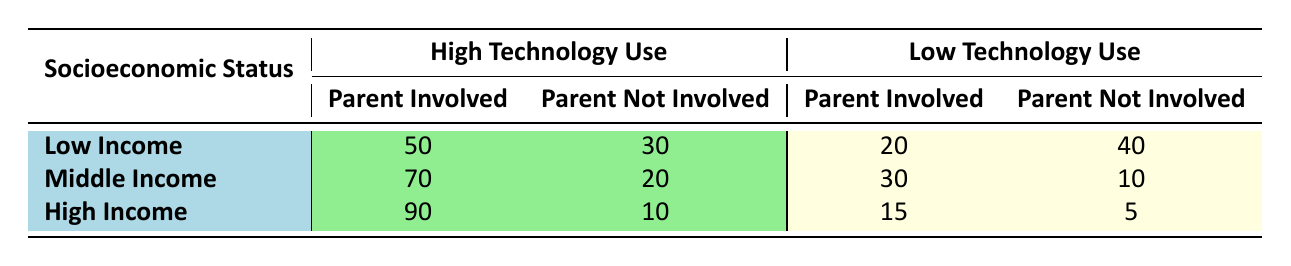What is the number of parents involved in technology-based learning activities for low-income students with high technology use? The table shows that for low-income students with high technology use, the number of parents involved is 50.
Answer: 50 How many high-income students have parents that are not involved in low technology use? According to the table, the number of high-income students whose parents are not involved in low technology use is 5.
Answer: 5 What is the total number of middle-income students with parents involved in both high and low technology use? For middle-income students, 70 are involved in high technology use and 30 in low technology use. Adding these gives 70 + 30 = 100 middle-income students with parent involvement.
Answer: 100 Is there a higher number of parents involved in technology-based activities among low-income or high-income students? By comparing the numbers, low-income students have 50 involved in high technology use and 20 in low technology use (total 70), while high-income students have 90 involved in high technology use and 15 in low technology use (total 105). Thus, there are more parents involved for high-income students.
Answer: Yes What is the difference in the number of parents not involved between middle-income and low-income students in high technology use? Middle income has 20 parents not involved in high technology use, while low income has 30. The difference is 30 - 20 = 10 parents.
Answer: 10 